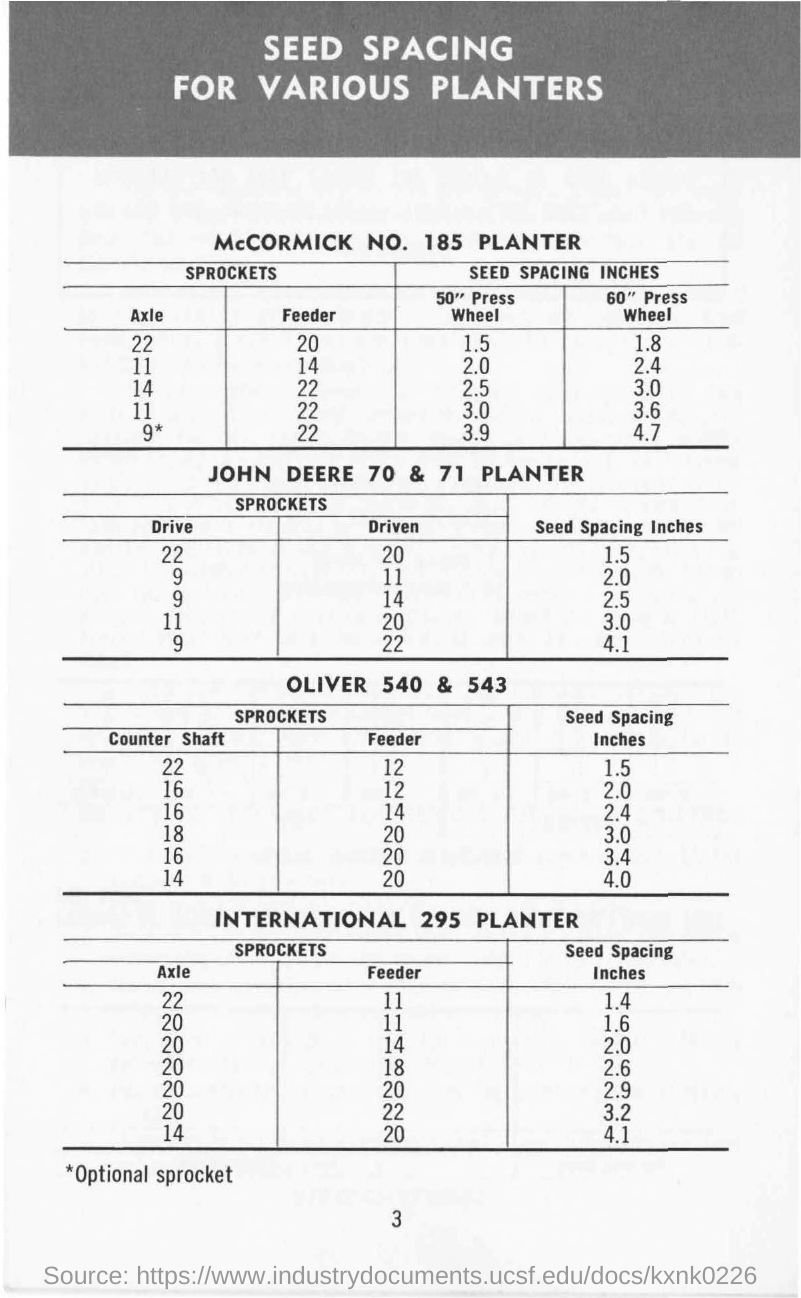What is the title of the document?
Keep it short and to the point. Seed Spacing for various planters. 